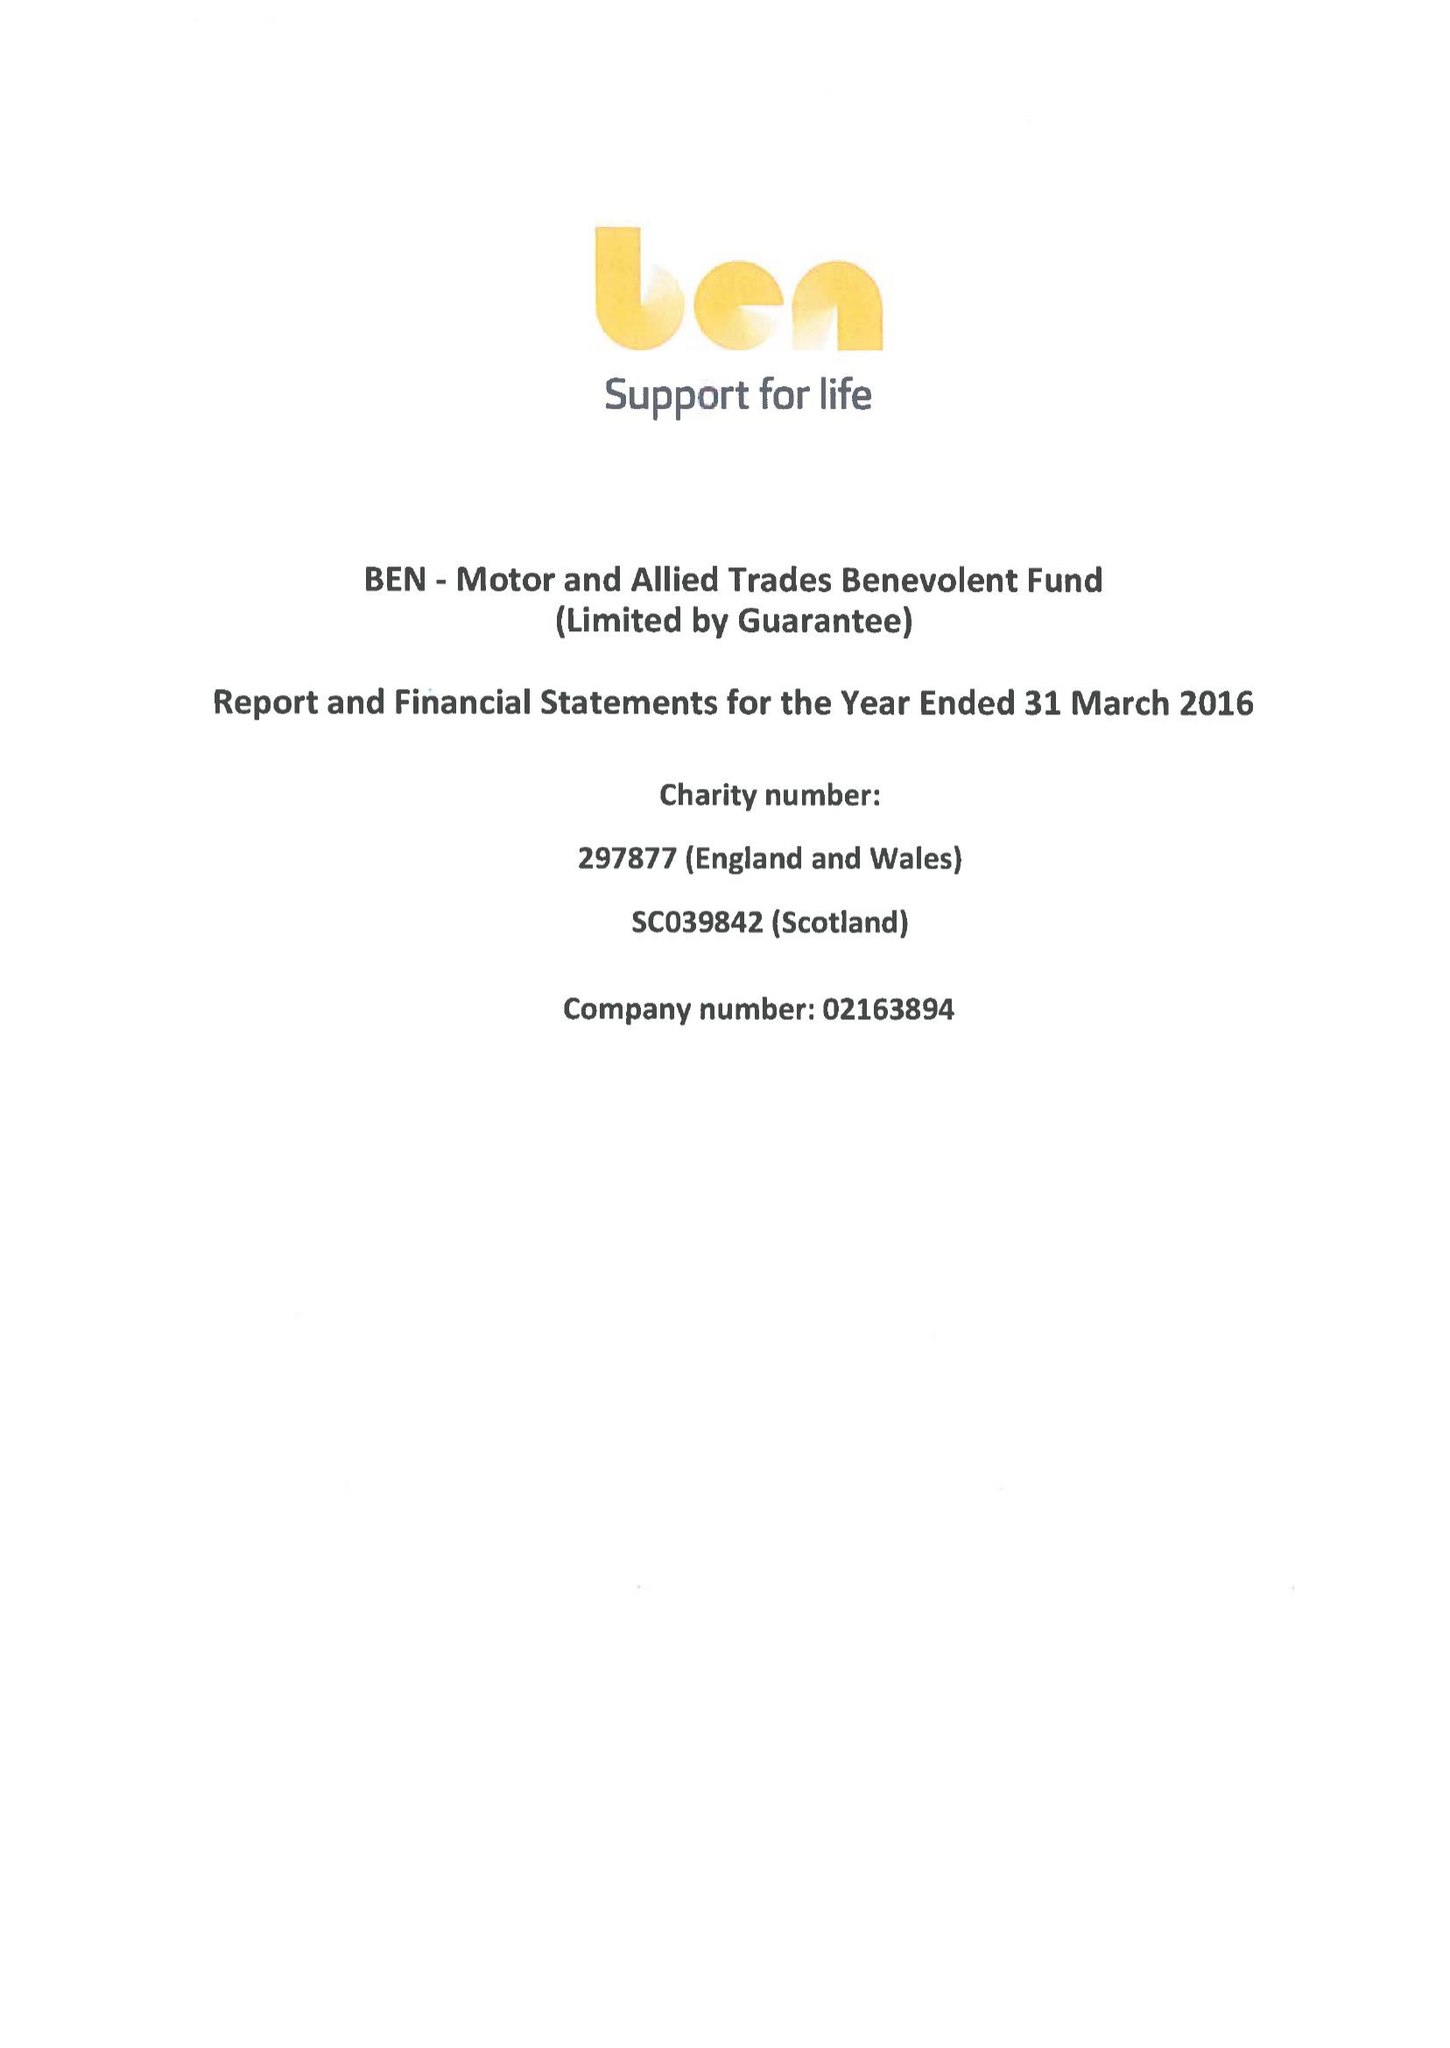What is the value for the address__street_line?
Answer the question using a single word or phrase. RISE ROAD 